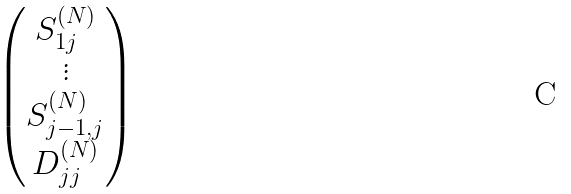Convert formula to latex. <formula><loc_0><loc_0><loc_500><loc_500>\begin{pmatrix} S _ { 1 j } ^ { ( N ) } \\ \vdots \\ S _ { j - 1 , j } ^ { ( N ) } \\ D _ { j j } ^ { ( N ) } \end{pmatrix}</formula> 